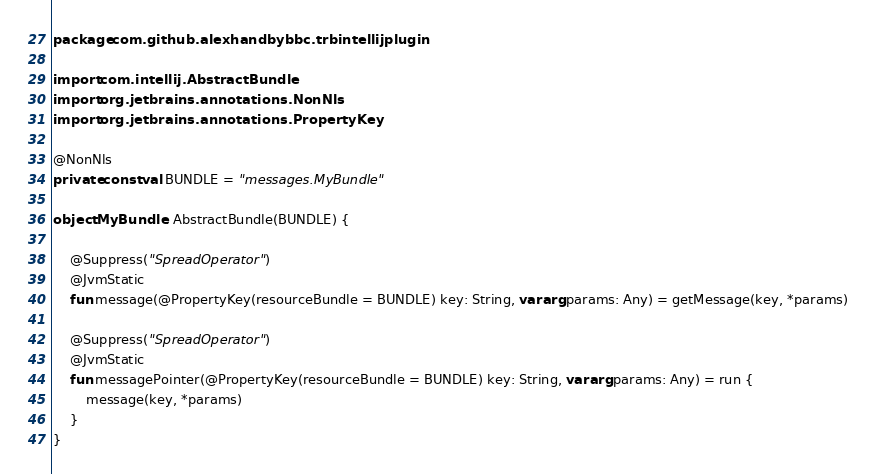Convert code to text. <code><loc_0><loc_0><loc_500><loc_500><_Kotlin_>package com.github.alexhandbybbc.trbintellijplugin

import com.intellij.AbstractBundle
import org.jetbrains.annotations.NonNls
import org.jetbrains.annotations.PropertyKey

@NonNls
private const val BUNDLE = "messages.MyBundle"

object MyBundle : AbstractBundle(BUNDLE) {

    @Suppress("SpreadOperator")
    @JvmStatic
    fun message(@PropertyKey(resourceBundle = BUNDLE) key: String, vararg params: Any) = getMessage(key, *params)

    @Suppress("SpreadOperator")
    @JvmStatic
    fun messagePointer(@PropertyKey(resourceBundle = BUNDLE) key: String, vararg params: Any) = run {
        message(key, *params)
    }
}
</code> 